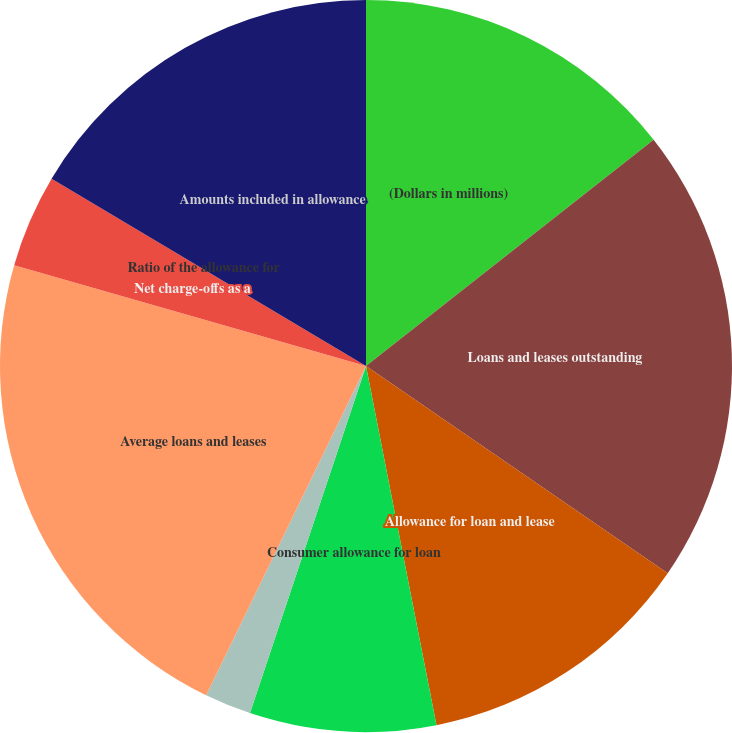Convert chart to OTSL. <chart><loc_0><loc_0><loc_500><loc_500><pie_chart><fcel>(Dollars in millions)<fcel>Loans and leases outstanding<fcel>Allowance for loan and lease<fcel>Consumer allowance for loan<fcel>Commercial allowance for loan<fcel>Average loans and leases<fcel>Net charge-offs as a<fcel>Ratio of the allowance for<fcel>Amounts included in allowance<nl><fcel>14.39%<fcel>20.19%<fcel>12.34%<fcel>8.22%<fcel>2.06%<fcel>22.25%<fcel>4.11%<fcel>0.0%<fcel>16.45%<nl></chart> 